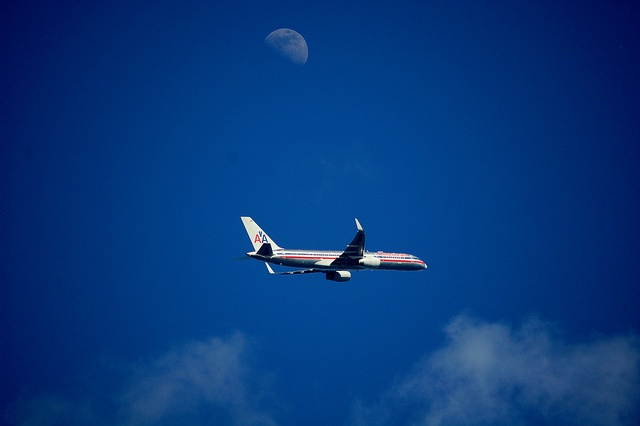Describe the objects in this image and their specific colors. I can see a airplane in navy, black, ivory, and darkgray tones in this image. 